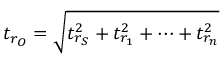Convert formula to latex. <formula><loc_0><loc_0><loc_500><loc_500>t _ { r _ { O } } = { \sqrt { t _ { r _ { S } } ^ { 2 } + t _ { r _ { 1 } } ^ { 2 } + \dots + t _ { r _ { n } } ^ { 2 } } }</formula> 